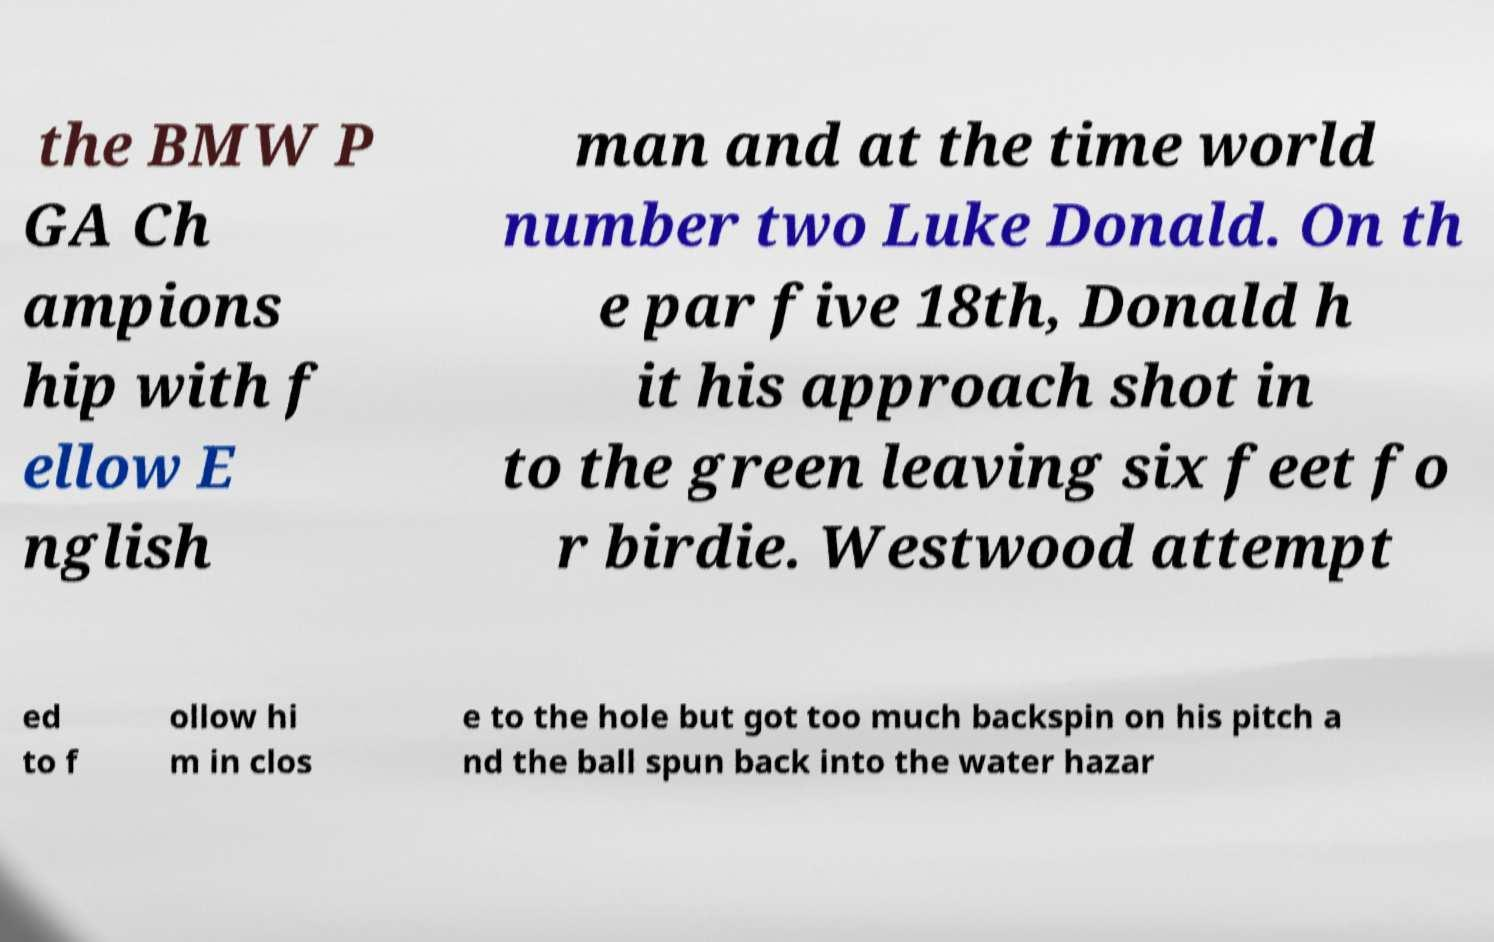There's text embedded in this image that I need extracted. Can you transcribe it verbatim? the BMW P GA Ch ampions hip with f ellow E nglish man and at the time world number two Luke Donald. On th e par five 18th, Donald h it his approach shot in to the green leaving six feet fo r birdie. Westwood attempt ed to f ollow hi m in clos e to the hole but got too much backspin on his pitch a nd the ball spun back into the water hazar 